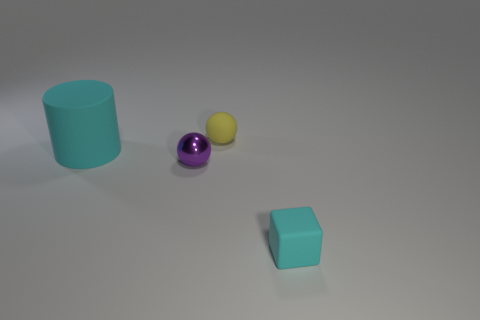Add 2 large red shiny spheres. How many objects exist? 6 Subtract all blocks. How many objects are left? 3 Subtract all tiny yellow matte spheres. Subtract all cyan rubber cylinders. How many objects are left? 2 Add 4 small matte balls. How many small matte balls are left? 5 Add 2 tiny cubes. How many tiny cubes exist? 3 Subtract 1 purple balls. How many objects are left? 3 